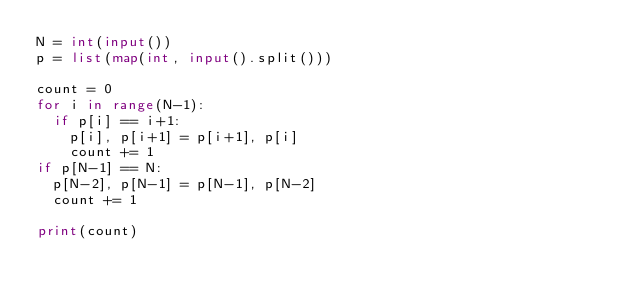Convert code to text. <code><loc_0><loc_0><loc_500><loc_500><_Python_>N = int(input())
p = list(map(int, input().split()))

count = 0
for i in range(N-1):
  if p[i] == i+1:
    p[i], p[i+1] = p[i+1], p[i]
    count += 1
if p[N-1] == N:
  p[N-2], p[N-1] = p[N-1], p[N-2]
  count += 1
  
print(count)</code> 